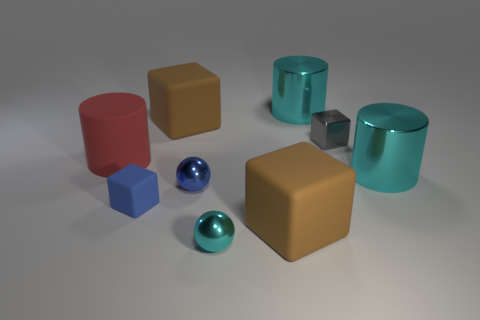Subtract all gray cubes. How many cubes are left? 3 Add 1 green shiny things. How many objects exist? 10 Subtract all gray blocks. How many blocks are left? 3 Subtract 1 cylinders. How many cylinders are left? 2 Subtract all yellow spheres. How many brown cubes are left? 2 Subtract all cylinders. How many objects are left? 6 Subtract all big matte cylinders. Subtract all large red cylinders. How many objects are left? 7 Add 3 tiny shiny objects. How many tiny shiny objects are left? 6 Add 5 metallic spheres. How many metallic spheres exist? 7 Subtract 0 brown balls. How many objects are left? 9 